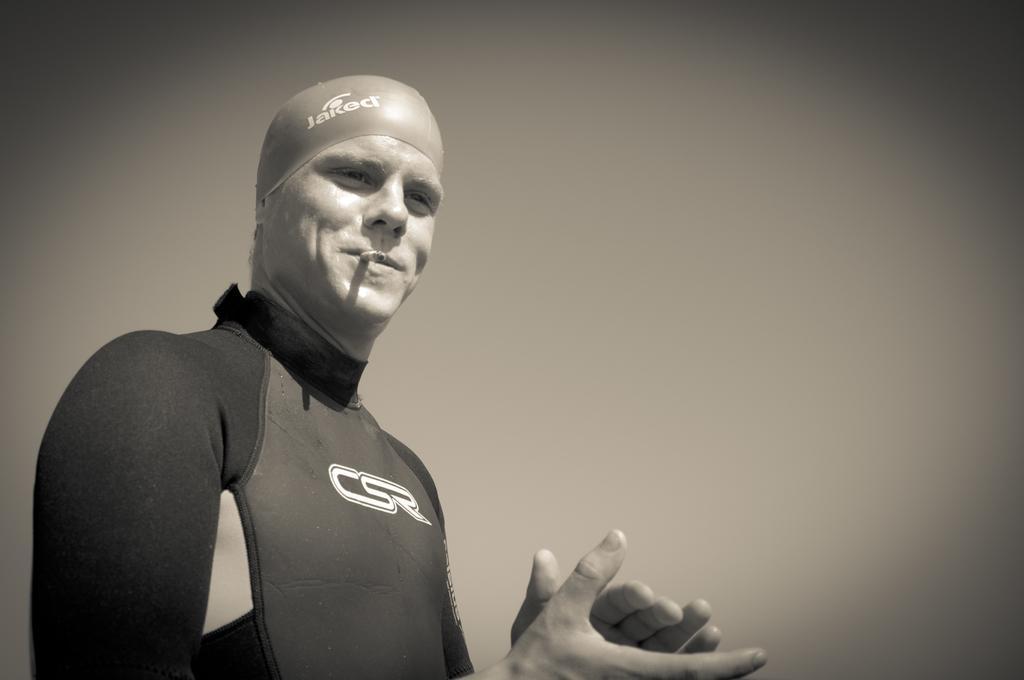How would you summarize this image in a sentence or two? In this image I can see a person standing and wearing dress. I can see cigarette. The image is in black and white. 